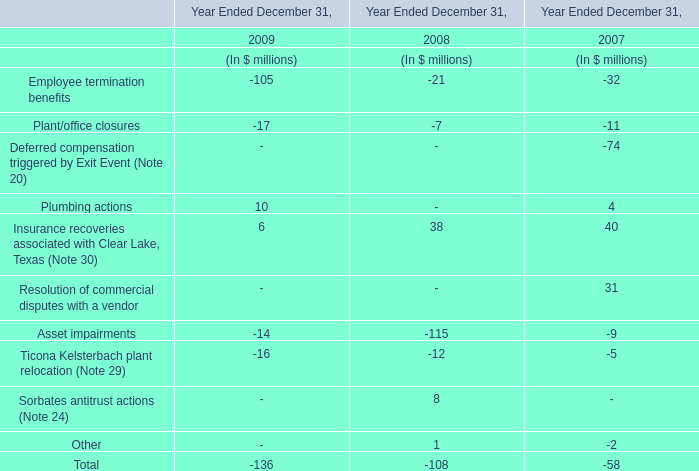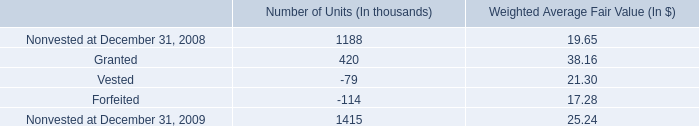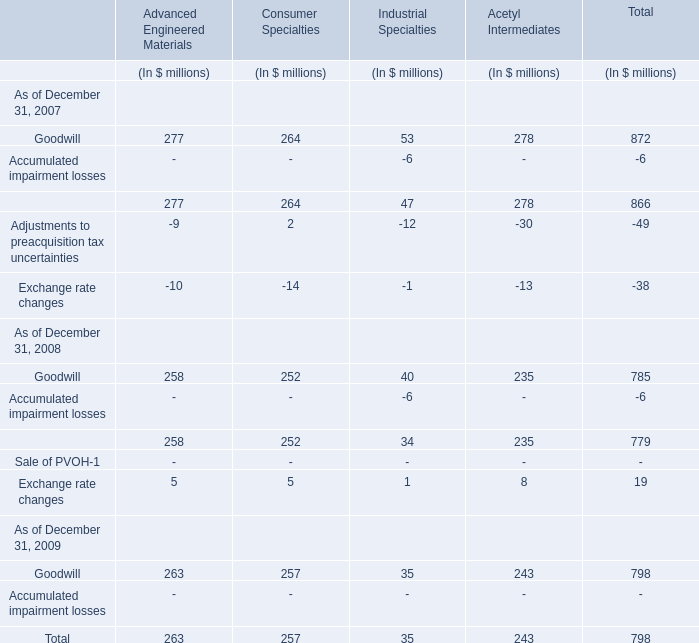what was the net change number of units in 2009 in thousands 
Computations: ((420 + -79) + -114)
Answer: 227.0. 